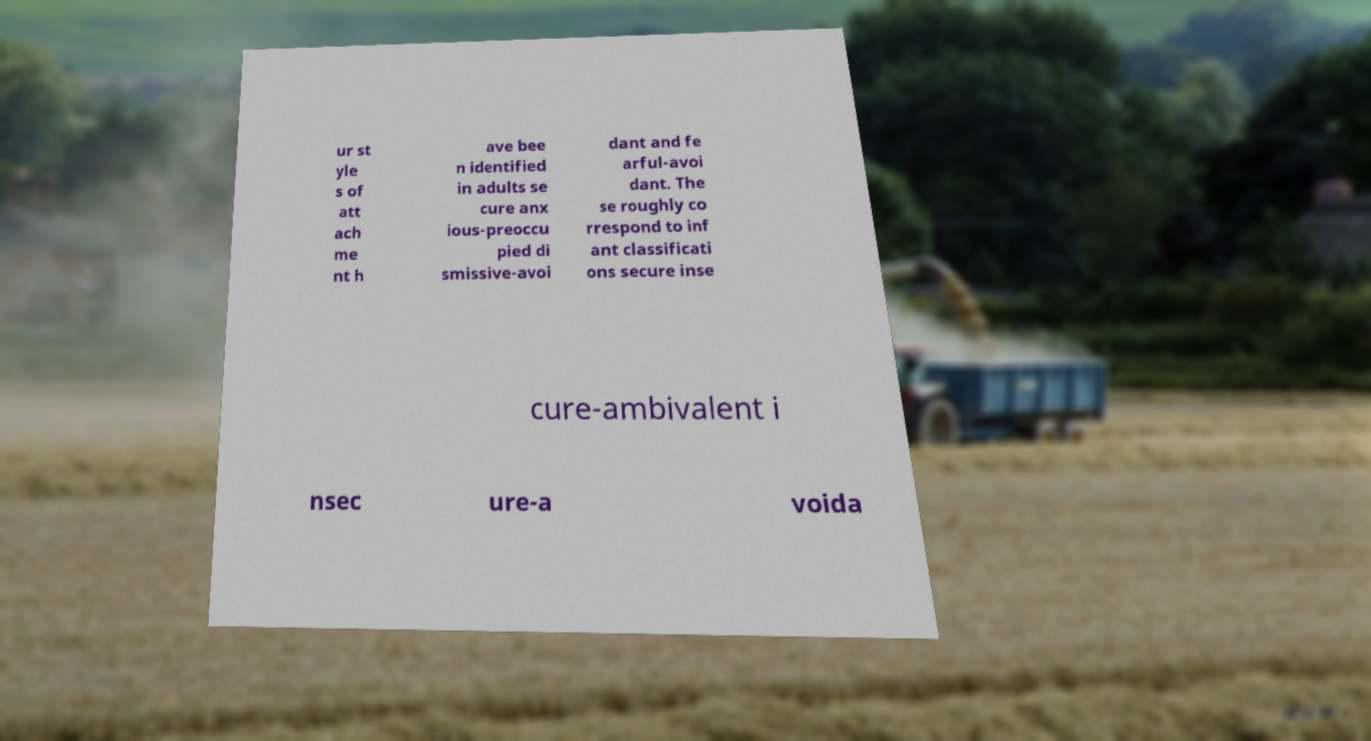What messages or text are displayed in this image? I need them in a readable, typed format. ur st yle s of att ach me nt h ave bee n identified in adults se cure anx ious-preoccu pied di smissive-avoi dant and fe arful-avoi dant. The se roughly co rrespond to inf ant classificati ons secure inse cure-ambivalent i nsec ure-a voida 